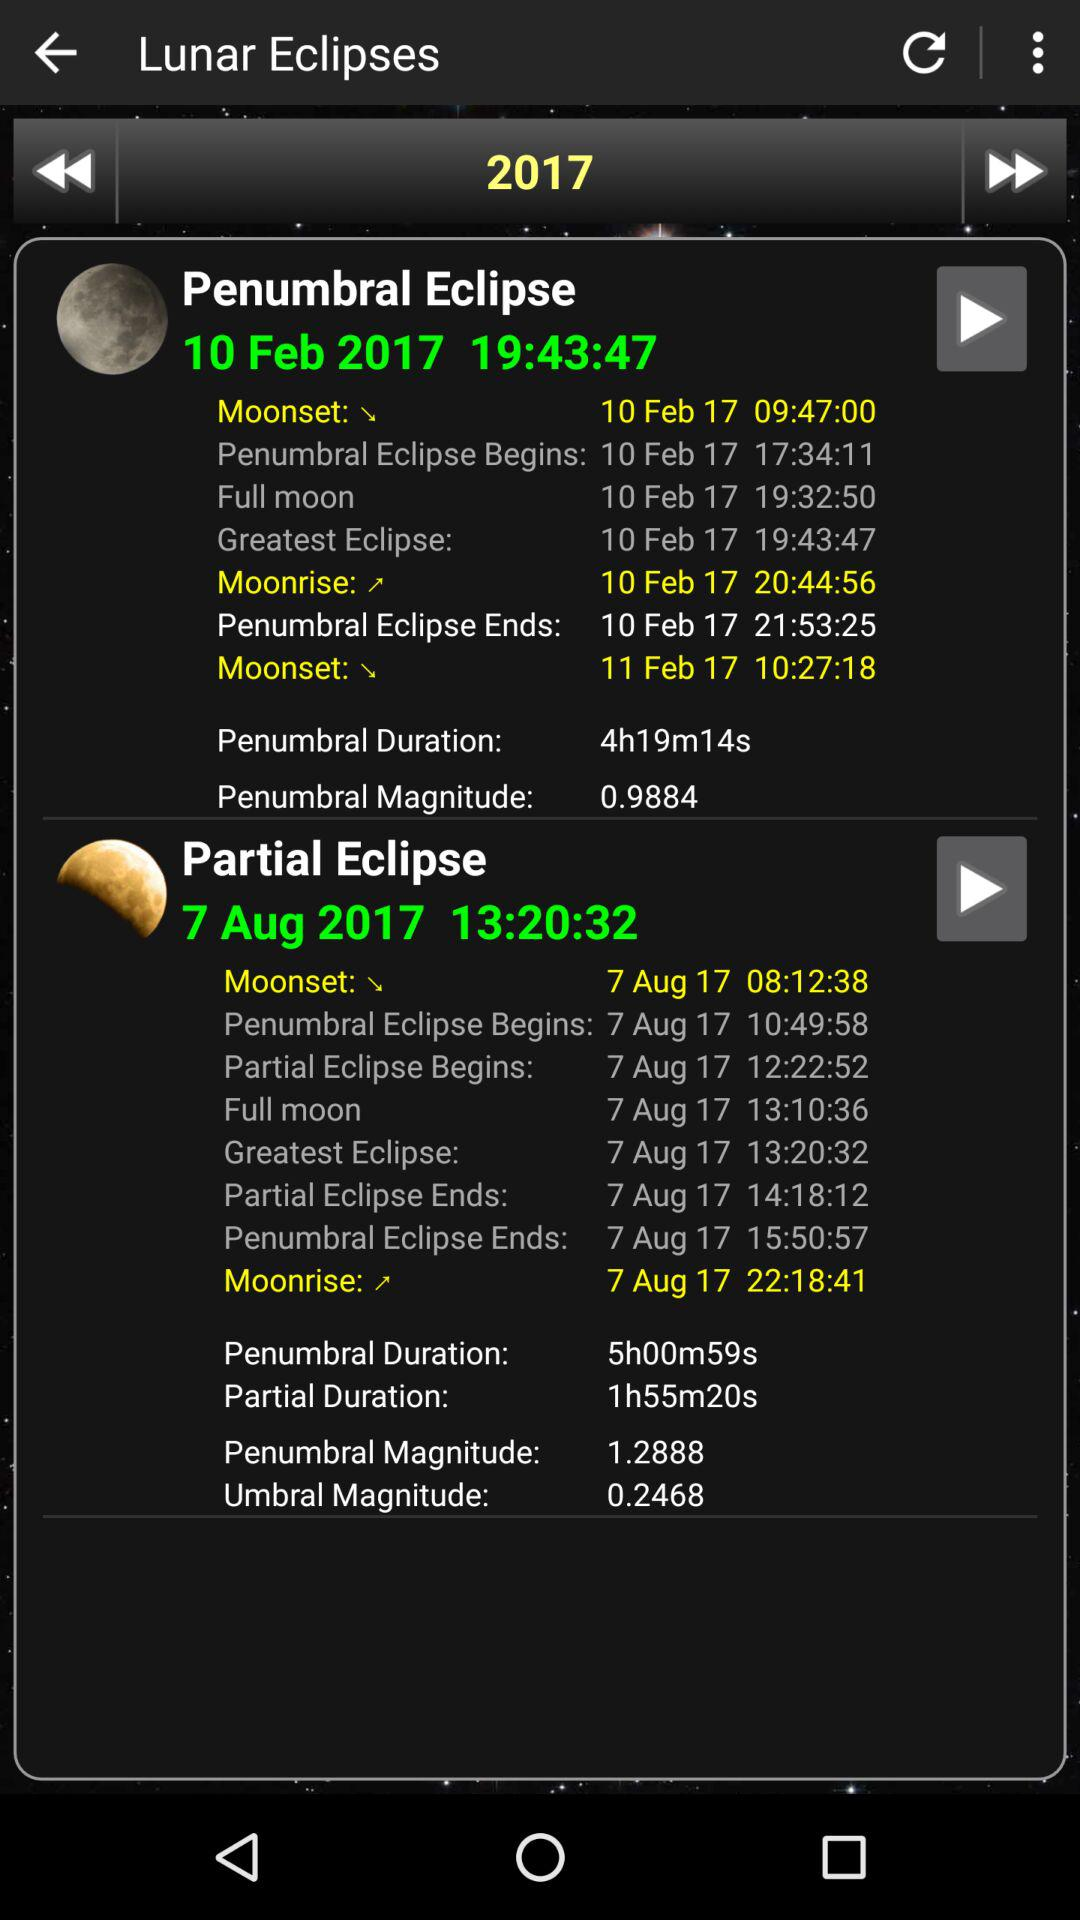What is the date of the penumbral eclipse? The date of the penumbral eclipse is February 10, 2017. 